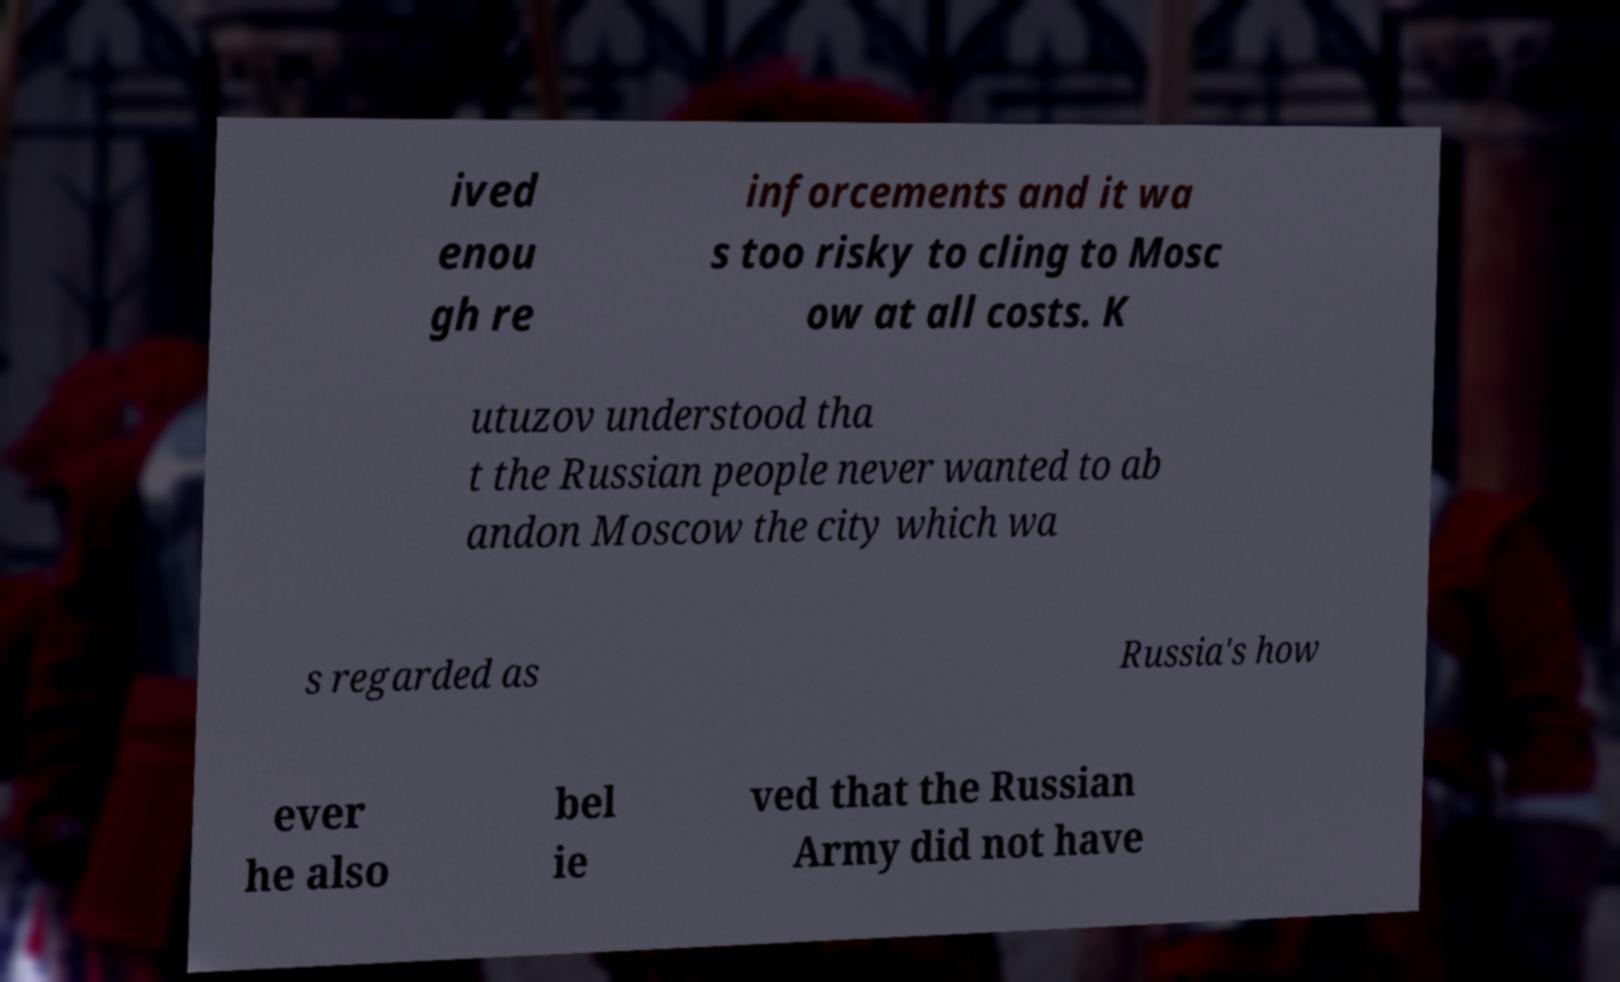I need the written content from this picture converted into text. Can you do that? ived enou gh re inforcements and it wa s too risky to cling to Mosc ow at all costs. K utuzov understood tha t the Russian people never wanted to ab andon Moscow the city which wa s regarded as Russia's how ever he also bel ie ved that the Russian Army did not have 